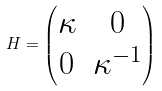<formula> <loc_0><loc_0><loc_500><loc_500>H = \begin{pmatrix} \kappa & 0 \\ 0 & \kappa ^ { - 1 } \end{pmatrix}</formula> 